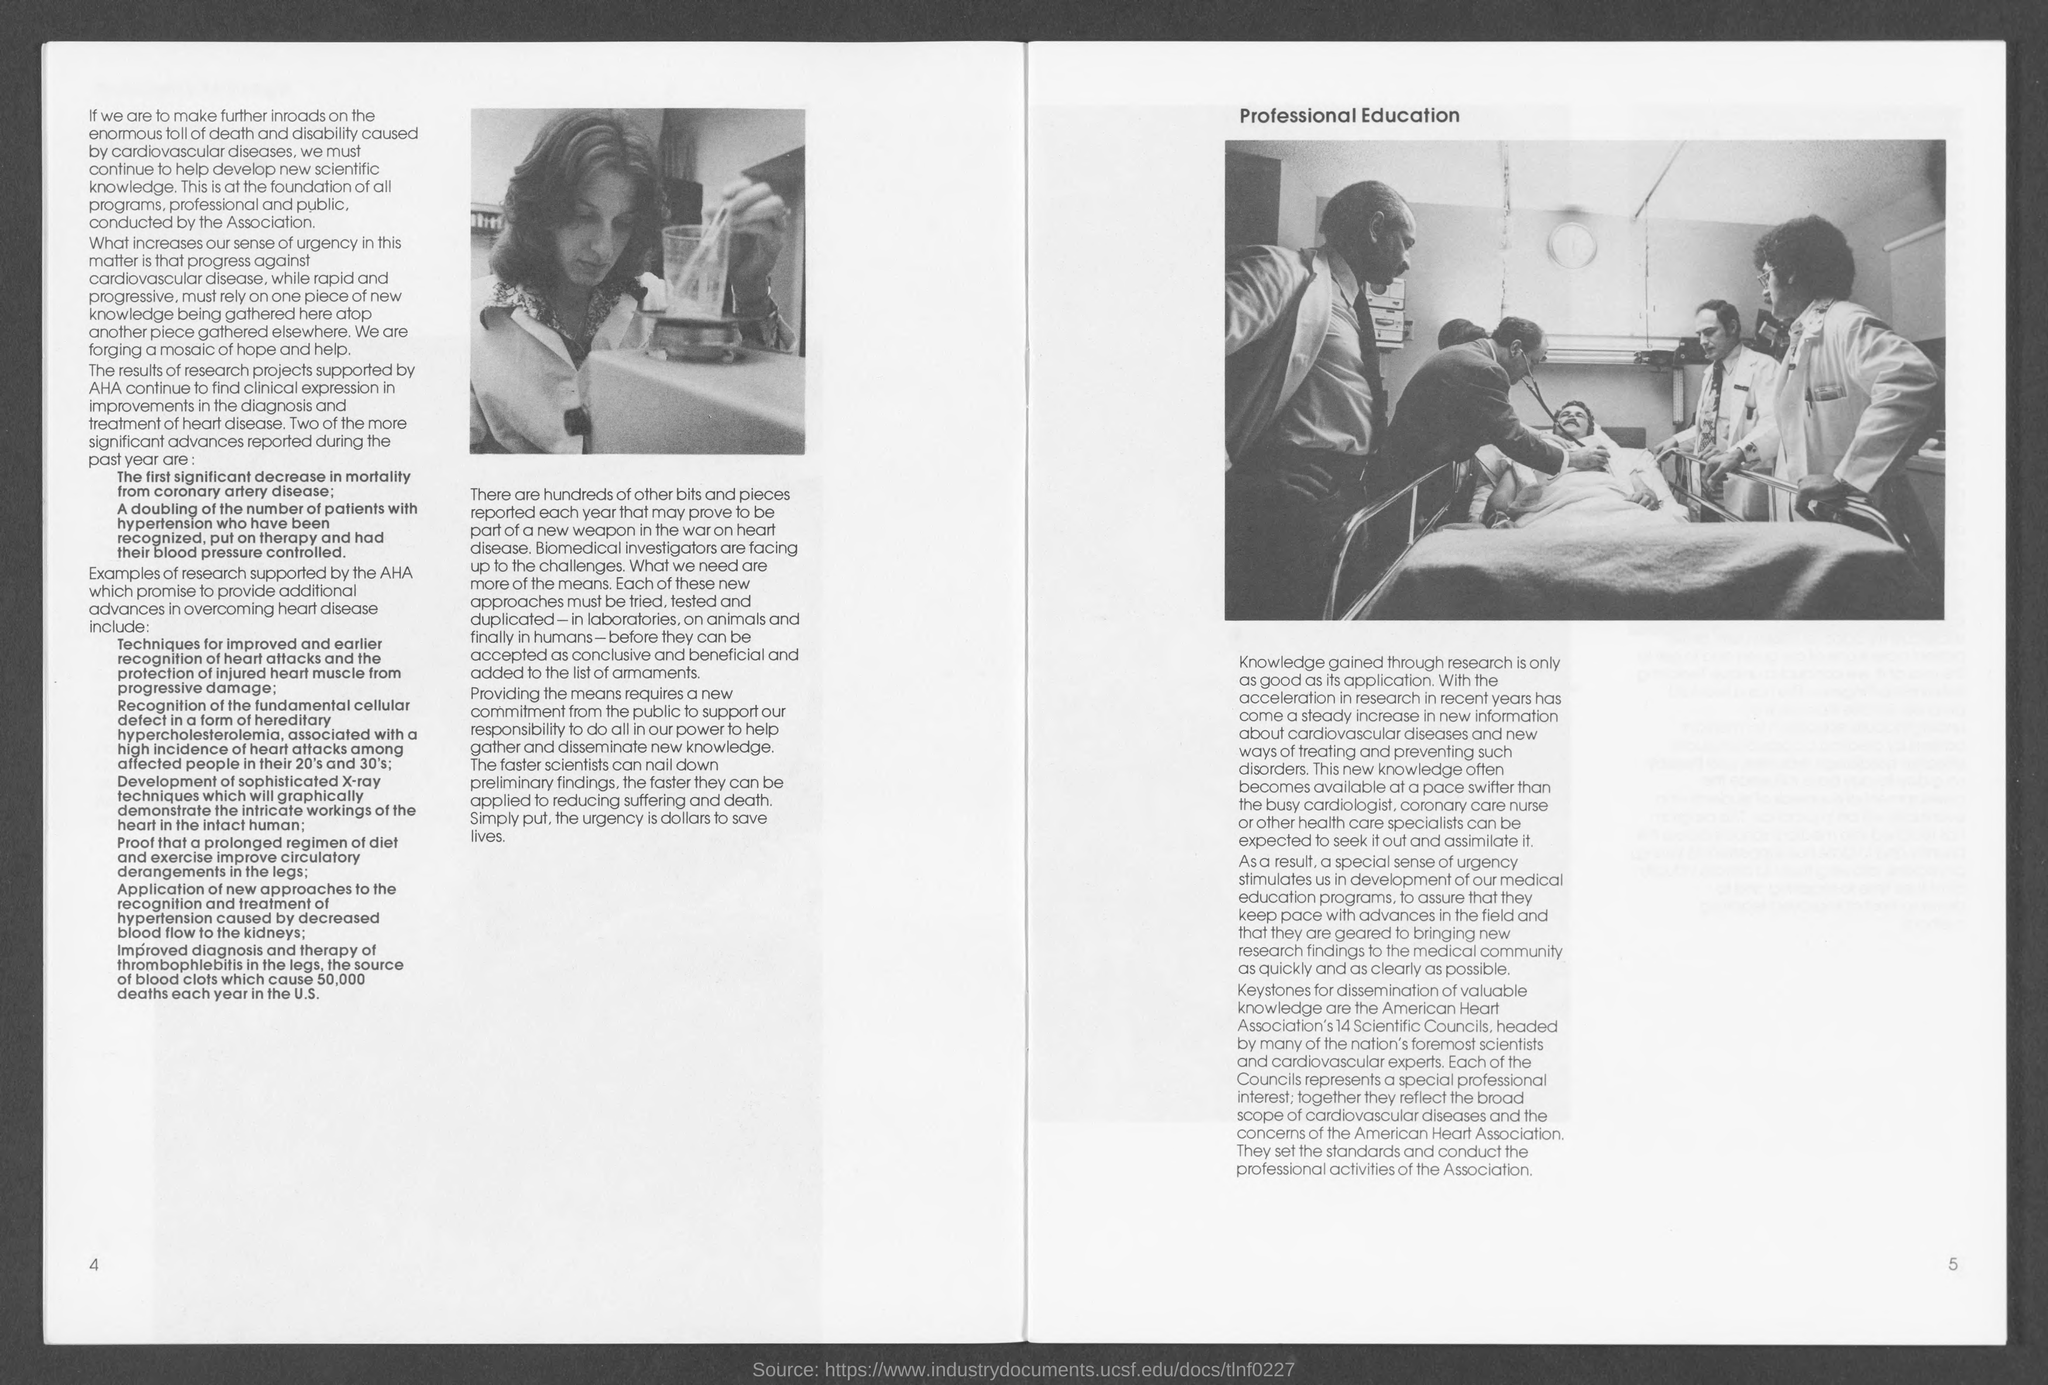What is the number at bottom left page ?
Your response must be concise. 4. What is the number at bottom right side ?
Your answer should be very brief. 5. 